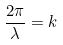Convert formula to latex. <formula><loc_0><loc_0><loc_500><loc_500>\frac { 2 \pi } { \lambda } = k</formula> 